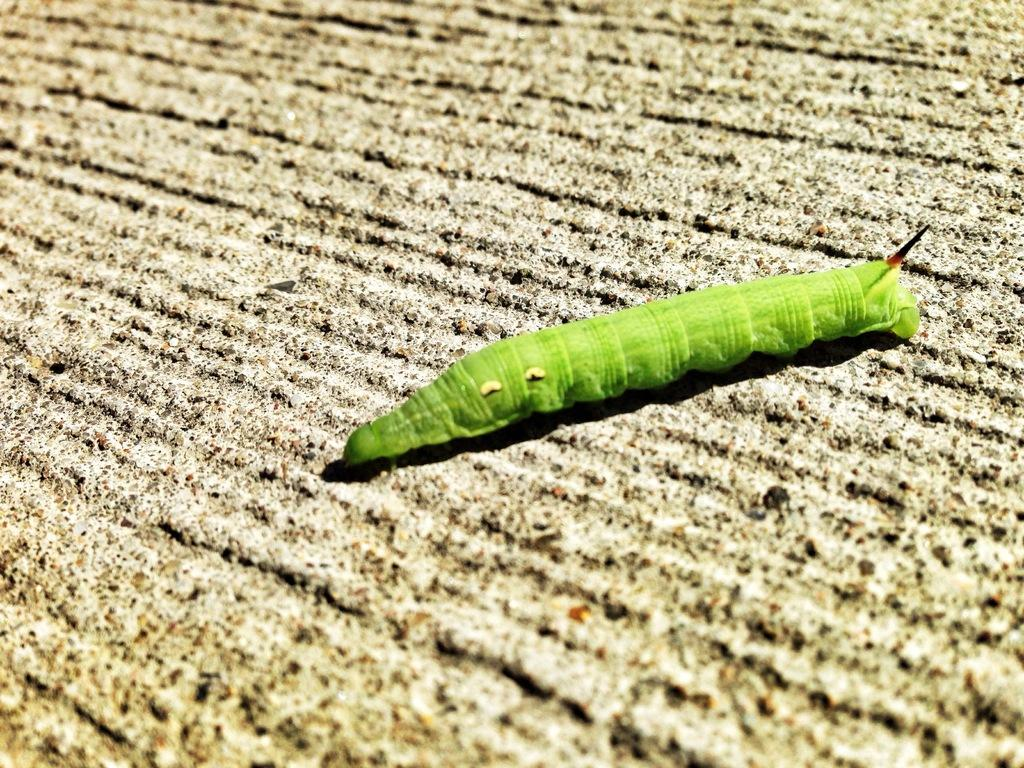What type of animal is present in the image? There is a caterpillar in the image. What color is the caterpillar? The caterpillar is green in color. What type of terrain is visible at the bottom of the image? There is land visible at the bottom of the image. What type of shoes is the caterpillar wearing in the image? There are no shoes present in the image, as the subject is a caterpillar, which does not wear shoes. 